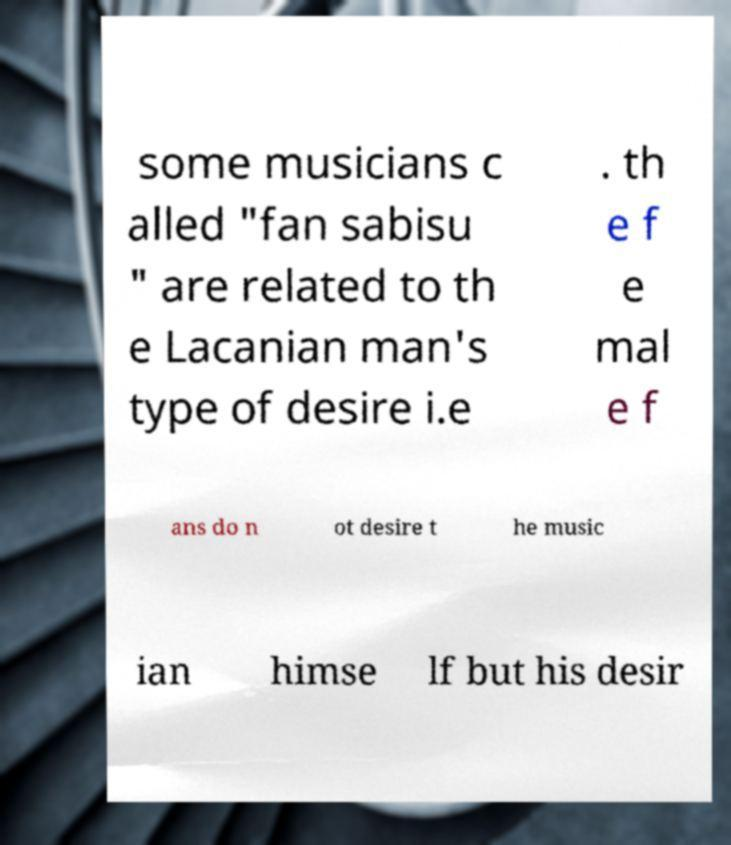I need the written content from this picture converted into text. Can you do that? some musicians c alled "fan sabisu " are related to th e Lacanian man's type of desire i.e . th e f e mal e f ans do n ot desire t he music ian himse lf but his desir 